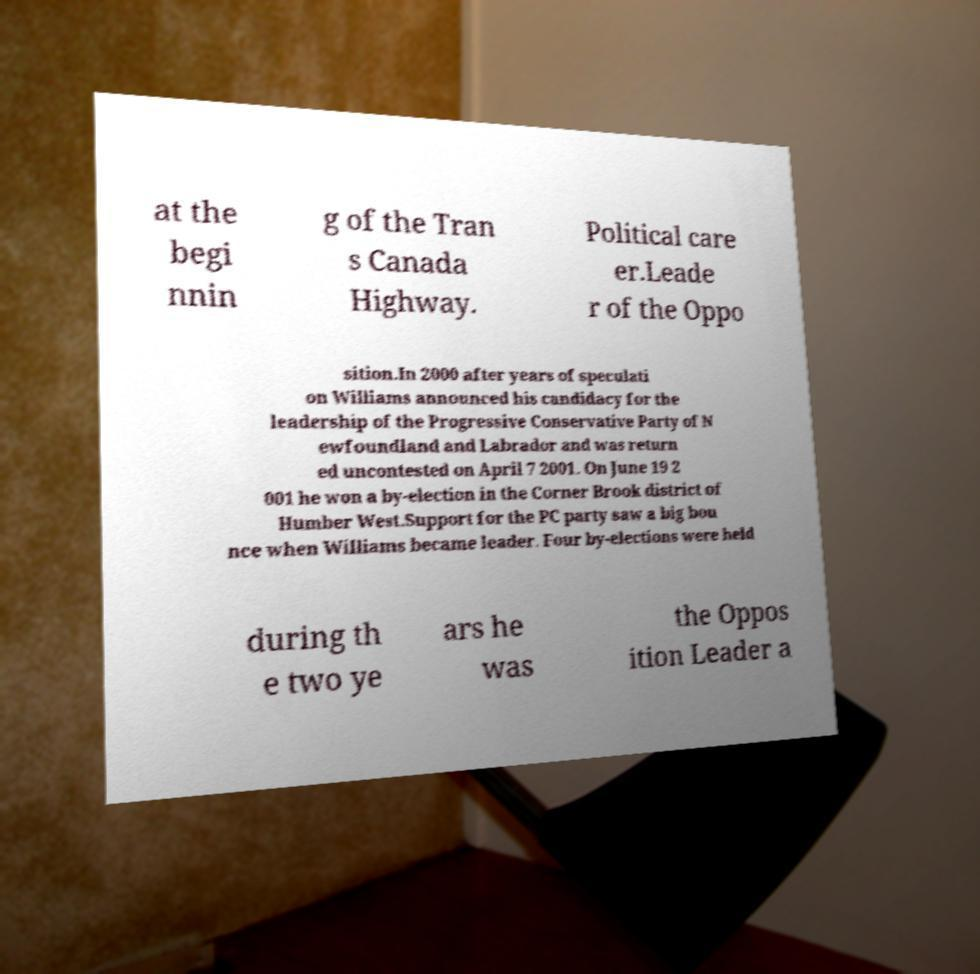Could you assist in decoding the text presented in this image and type it out clearly? at the begi nnin g of the Tran s Canada Highway. Political care er.Leade r of the Oppo sition.In 2000 after years of speculati on Williams announced his candidacy for the leadership of the Progressive Conservative Party of N ewfoundland and Labrador and was return ed uncontested on April 7 2001. On June 19 2 001 he won a by-election in the Corner Brook district of Humber West.Support for the PC party saw a big bou nce when Williams became leader. Four by-elections were held during th e two ye ars he was the Oppos ition Leader a 